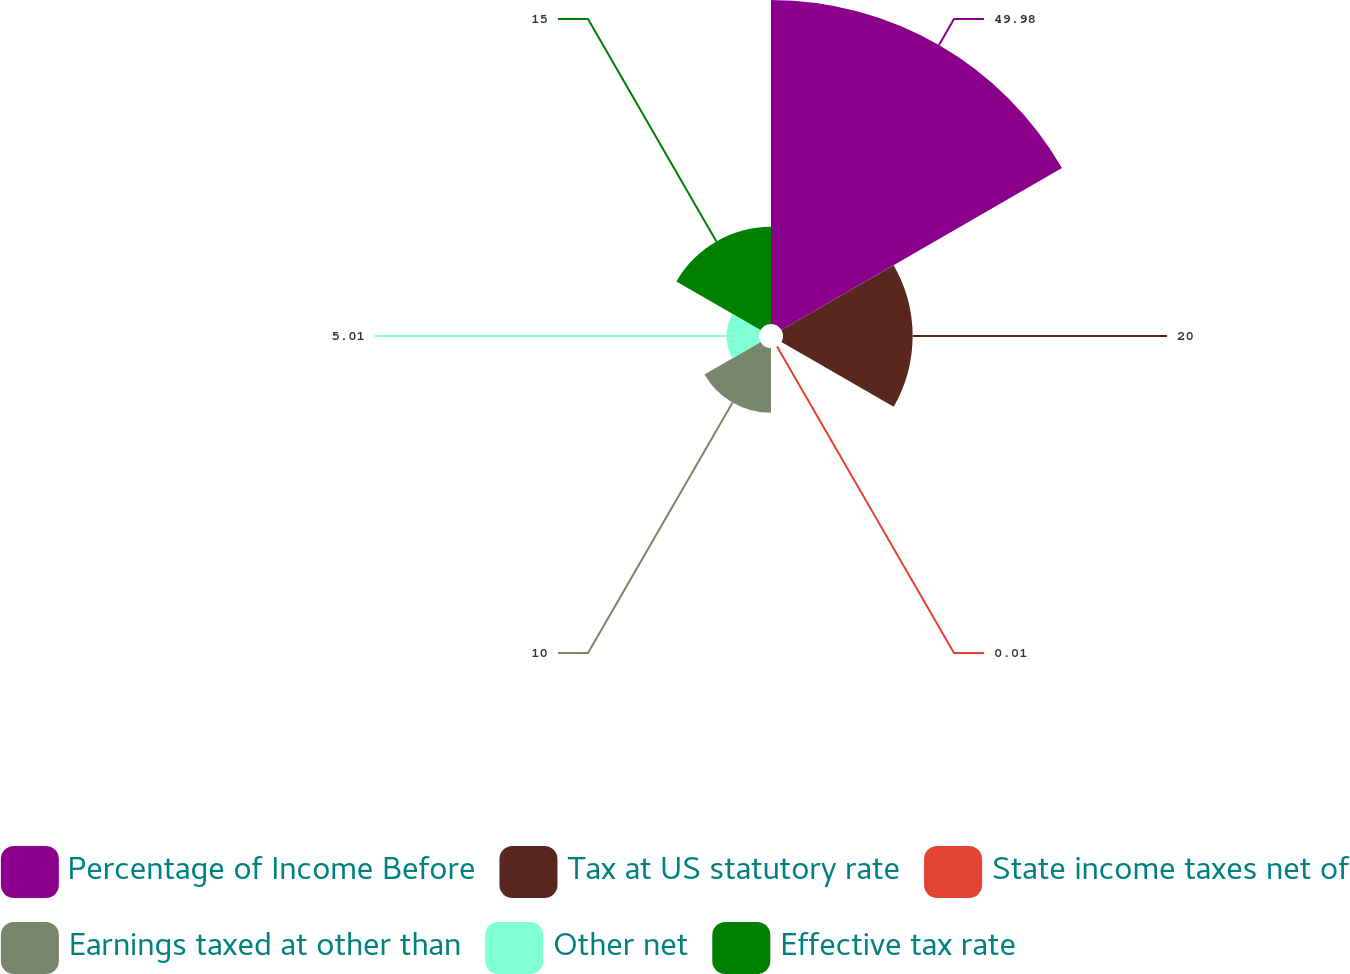Convert chart. <chart><loc_0><loc_0><loc_500><loc_500><pie_chart><fcel>Percentage of Income Before<fcel>Tax at US statutory rate<fcel>State income taxes net of<fcel>Earnings taxed at other than<fcel>Other net<fcel>Effective tax rate<nl><fcel>49.98%<fcel>20.0%<fcel>0.01%<fcel>10.0%<fcel>5.01%<fcel>15.0%<nl></chart> 